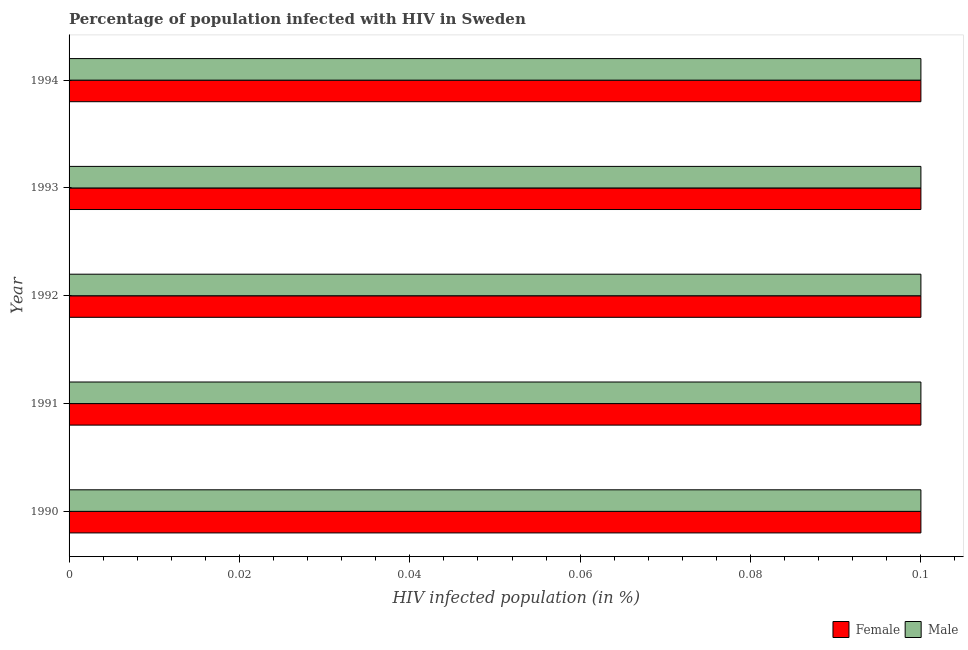Are the number of bars per tick equal to the number of legend labels?
Provide a short and direct response. Yes. How many bars are there on the 3rd tick from the bottom?
Offer a very short reply. 2. What is the label of the 3rd group of bars from the top?
Provide a succinct answer. 1992. Across all years, what is the maximum percentage of males who are infected with hiv?
Your answer should be very brief. 0.1. Across all years, what is the minimum percentage of males who are infected with hiv?
Make the answer very short. 0.1. In which year was the percentage of females who are infected with hiv maximum?
Your response must be concise. 1990. In which year was the percentage of males who are infected with hiv minimum?
Provide a succinct answer. 1990. What is the total percentage of males who are infected with hiv in the graph?
Make the answer very short. 0.5. What is the difference between the percentage of females who are infected with hiv in 1991 and that in 1993?
Your response must be concise. 0. What is the difference between the percentage of males who are infected with hiv in 1992 and the percentage of females who are infected with hiv in 1993?
Offer a terse response. 0. In the year 1990, what is the difference between the percentage of females who are infected with hiv and percentage of males who are infected with hiv?
Keep it short and to the point. 0. What is the ratio of the percentage of females who are infected with hiv in 1990 to that in 1993?
Give a very brief answer. 1. Is the percentage of females who are infected with hiv in 1990 less than that in 1991?
Keep it short and to the point. No. Is the difference between the percentage of females who are infected with hiv in 1990 and 1993 greater than the difference between the percentage of males who are infected with hiv in 1990 and 1993?
Offer a very short reply. No. What is the difference between the highest and the lowest percentage of males who are infected with hiv?
Provide a short and direct response. 0. In how many years, is the percentage of females who are infected with hiv greater than the average percentage of females who are infected with hiv taken over all years?
Your answer should be very brief. 0. Is the sum of the percentage of males who are infected with hiv in 1991 and 1992 greater than the maximum percentage of females who are infected with hiv across all years?
Ensure brevity in your answer.  Yes. What does the 2nd bar from the top in 1994 represents?
Your answer should be compact. Female. What does the 1st bar from the bottom in 1994 represents?
Make the answer very short. Female. How many bars are there?
Provide a succinct answer. 10. What is the difference between two consecutive major ticks on the X-axis?
Make the answer very short. 0.02. Are the values on the major ticks of X-axis written in scientific E-notation?
Your answer should be compact. No. Does the graph contain grids?
Ensure brevity in your answer.  No. How are the legend labels stacked?
Make the answer very short. Horizontal. What is the title of the graph?
Your response must be concise. Percentage of population infected with HIV in Sweden. Does "Food" appear as one of the legend labels in the graph?
Provide a short and direct response. No. What is the label or title of the X-axis?
Keep it short and to the point. HIV infected population (in %). What is the label or title of the Y-axis?
Your response must be concise. Year. What is the HIV infected population (in %) in Female in 1990?
Your answer should be very brief. 0.1. What is the HIV infected population (in %) of Male in 1990?
Your answer should be very brief. 0.1. What is the HIV infected population (in %) of Female in 1991?
Your answer should be compact. 0.1. What is the HIV infected population (in %) of Male in 1991?
Ensure brevity in your answer.  0.1. What is the HIV infected population (in %) of Female in 1992?
Keep it short and to the point. 0.1. What is the HIV infected population (in %) in Male in 1994?
Ensure brevity in your answer.  0.1. Across all years, what is the maximum HIV infected population (in %) of Male?
Keep it short and to the point. 0.1. Across all years, what is the minimum HIV infected population (in %) of Male?
Provide a short and direct response. 0.1. What is the total HIV infected population (in %) in Female in the graph?
Provide a short and direct response. 0.5. What is the total HIV infected population (in %) in Male in the graph?
Ensure brevity in your answer.  0.5. What is the difference between the HIV infected population (in %) in Male in 1990 and that in 1991?
Provide a succinct answer. 0. What is the difference between the HIV infected population (in %) in Female in 1990 and that in 1992?
Provide a succinct answer. 0. What is the difference between the HIV infected population (in %) of Male in 1990 and that in 1992?
Keep it short and to the point. 0. What is the difference between the HIV infected population (in %) of Male in 1990 and that in 1993?
Offer a terse response. 0. What is the difference between the HIV infected population (in %) of Female in 1990 and that in 1994?
Make the answer very short. 0. What is the difference between the HIV infected population (in %) in Male in 1990 and that in 1994?
Make the answer very short. 0. What is the difference between the HIV infected population (in %) of Male in 1991 and that in 1992?
Provide a short and direct response. 0. What is the difference between the HIV infected population (in %) of Female in 1991 and that in 1993?
Give a very brief answer. 0. What is the difference between the HIV infected population (in %) of Female in 1992 and that in 1993?
Your response must be concise. 0. What is the difference between the HIV infected population (in %) in Female in 1992 and that in 1994?
Offer a terse response. 0. What is the difference between the HIV infected population (in %) of Female in 1990 and the HIV infected population (in %) of Male in 1991?
Ensure brevity in your answer.  0. What is the difference between the HIV infected population (in %) of Female in 1990 and the HIV infected population (in %) of Male in 1993?
Provide a short and direct response. 0. What is the difference between the HIV infected population (in %) in Female in 1991 and the HIV infected population (in %) in Male in 1992?
Offer a very short reply. 0. What is the difference between the HIV infected population (in %) of Female in 1992 and the HIV infected population (in %) of Male in 1993?
Offer a very short reply. 0. What is the difference between the HIV infected population (in %) in Female in 1992 and the HIV infected population (in %) in Male in 1994?
Your answer should be compact. 0. What is the difference between the HIV infected population (in %) of Female in 1993 and the HIV infected population (in %) of Male in 1994?
Ensure brevity in your answer.  0. What is the average HIV infected population (in %) in Male per year?
Your answer should be compact. 0.1. In the year 1991, what is the difference between the HIV infected population (in %) in Female and HIV infected population (in %) in Male?
Provide a short and direct response. 0. In the year 1993, what is the difference between the HIV infected population (in %) in Female and HIV infected population (in %) in Male?
Offer a terse response. 0. What is the ratio of the HIV infected population (in %) in Female in 1990 to that in 1991?
Your answer should be very brief. 1. What is the ratio of the HIV infected population (in %) of Male in 1990 to that in 1991?
Your response must be concise. 1. What is the ratio of the HIV infected population (in %) in Male in 1990 to that in 1992?
Your response must be concise. 1. What is the ratio of the HIV infected population (in %) in Female in 1990 to that in 1993?
Keep it short and to the point. 1. What is the ratio of the HIV infected population (in %) of Male in 1990 to that in 1994?
Your answer should be compact. 1. What is the ratio of the HIV infected population (in %) in Female in 1991 to that in 1993?
Offer a very short reply. 1. What is the ratio of the HIV infected population (in %) in Male in 1991 to that in 1993?
Your answer should be very brief. 1. What is the ratio of the HIV infected population (in %) of Female in 1992 to that in 1993?
Your answer should be compact. 1. What is the ratio of the HIV infected population (in %) in Male in 1992 to that in 1993?
Offer a terse response. 1. What is the ratio of the HIV infected population (in %) of Female in 1992 to that in 1994?
Ensure brevity in your answer.  1. What is the ratio of the HIV infected population (in %) of Female in 1993 to that in 1994?
Offer a very short reply. 1. 